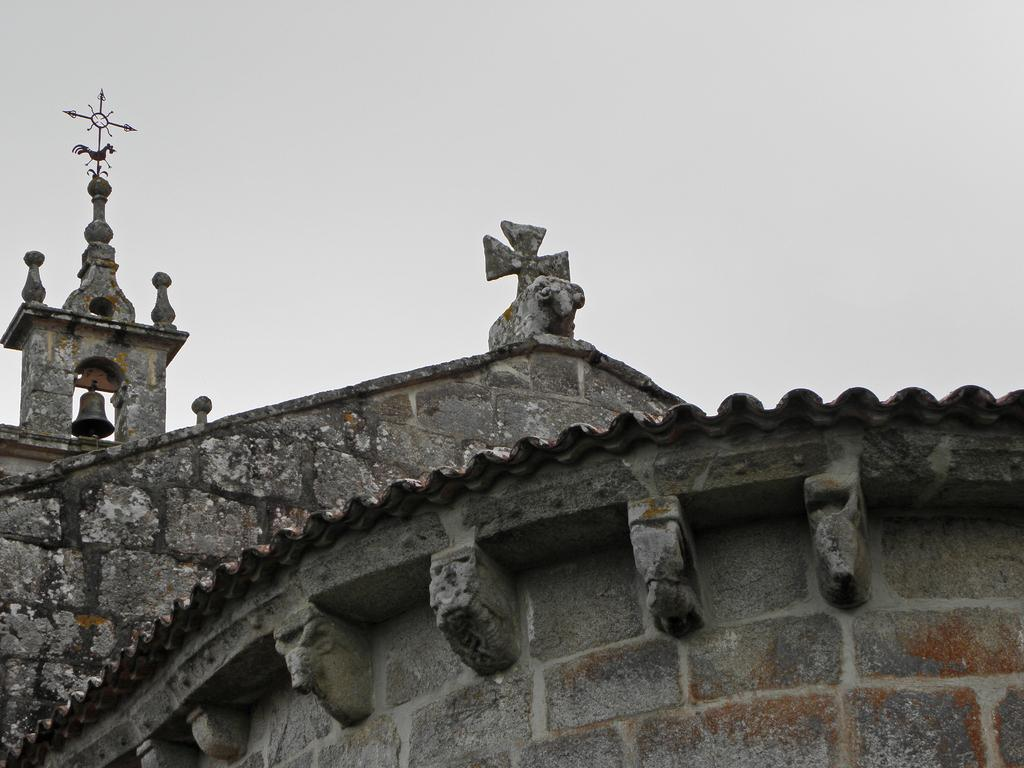What can be seen in the sky in the image? The sky is visible in the image, but no specific details about the sky can be determined from the provided facts. What type of building is present in the image? There is an old building in the image. What is hanging in the image? The bell is hanging in the image. Where is the iron metal horse located in the image? The iron metal horse is designed and kept on the top of the building. What type of beam is supporting the bell in the image? There is no information about a beam supporting the bell in the image. What part of the building is the bell attached to? The provided facts do not specify which part of the building the bell is attached to. 